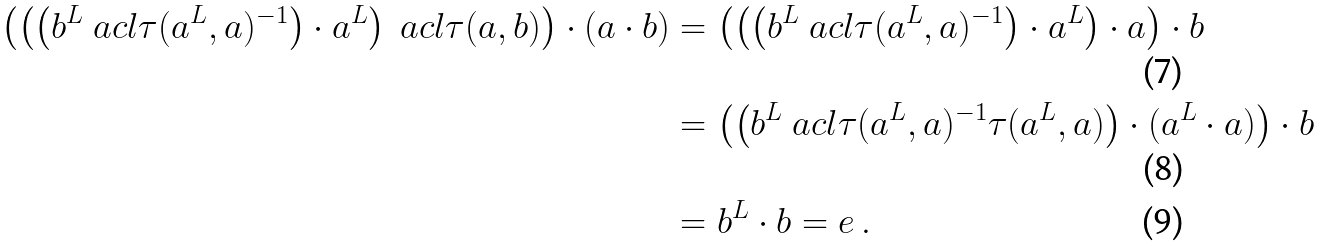Convert formula to latex. <formula><loc_0><loc_0><loc_500><loc_500>\left ( \left ( \left ( b ^ { L } \ a c l \tau ( a ^ { L } , a ) ^ { - 1 } \right ) \cdot a ^ { L } \right ) \ a c l \tau ( a , b ) \right ) \cdot ( a \cdot b ) & = \left ( \left ( \left ( b ^ { L } \ a c l \tau ( a ^ { L } , a ) ^ { - 1 } \right ) \cdot a ^ { L } \right ) \cdot a \right ) \cdot b \\ & = \left ( \left ( b ^ { L } \ a c l \tau ( a ^ { L } , a ) ^ { - 1 } \tau ( a ^ { L } , a ) \right ) \cdot ( a ^ { L } \cdot a ) \right ) \cdot b \\ & = b ^ { L } \cdot b = e \, .</formula> 